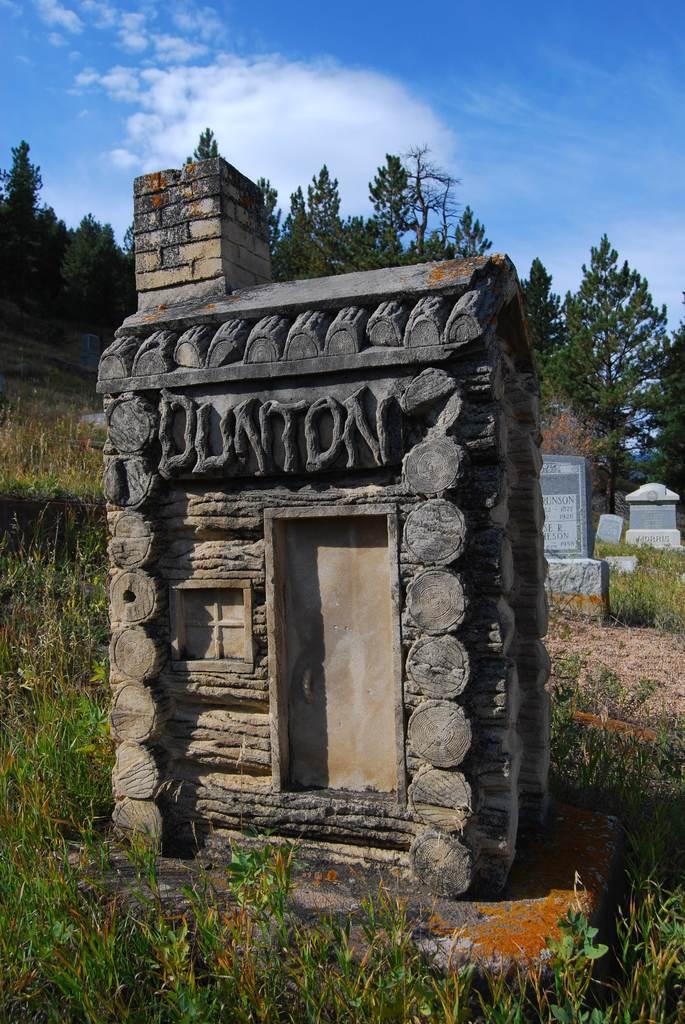What name is carved in the rocks?
Ensure brevity in your answer.  Dunton. 